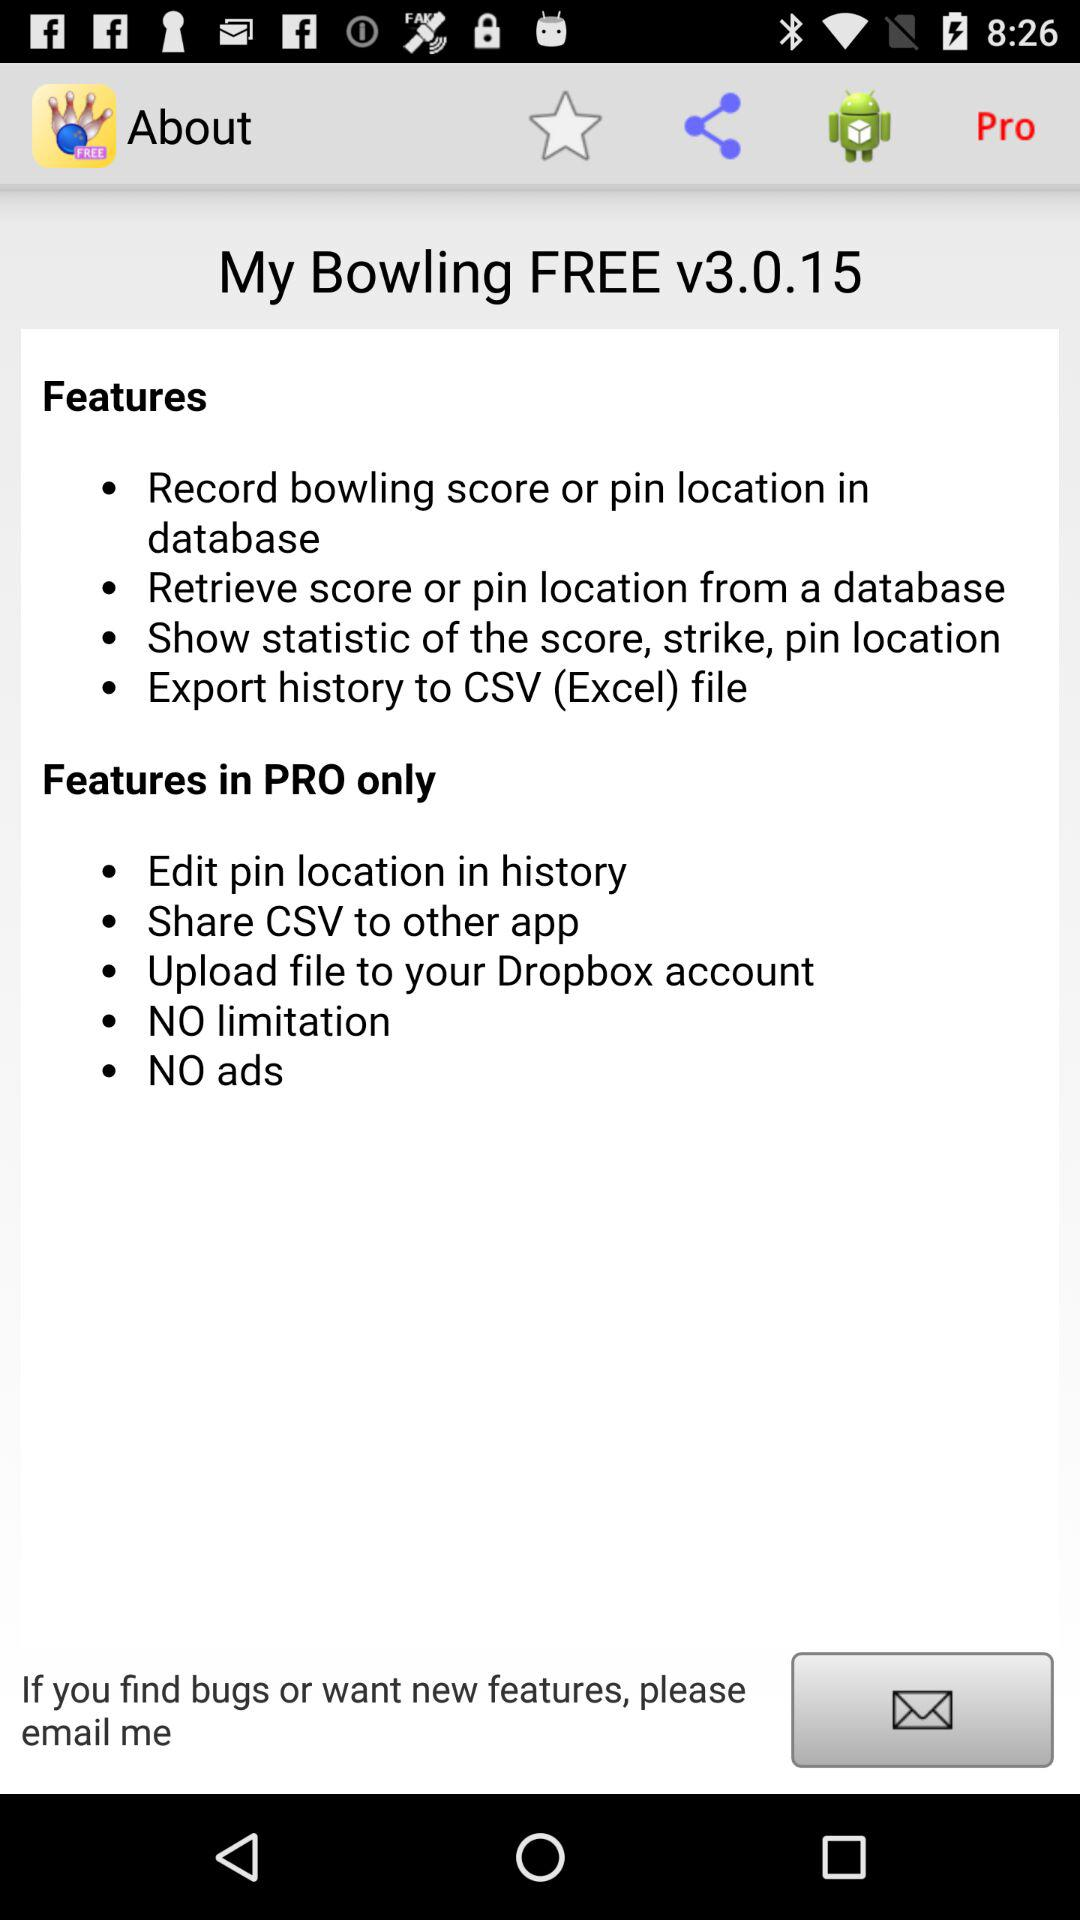What are the features of the free version of the application? The features of the free version are "Record bowling score or pin location in database", "Retrieve score or pin location from a database", "Show statistic of the score, strike, pin location" and "Export history to CSV (Excel) file". 